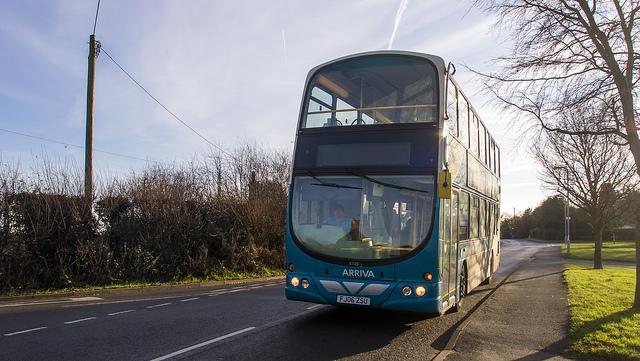Where is the bus going?
Give a very brief answer. On tour. The bus is clean?
Keep it brief. Yes. Is this a clean looking double Decker bus?
Keep it brief. Yes. What kind of bus is this?
Concise answer only. Double decker. 